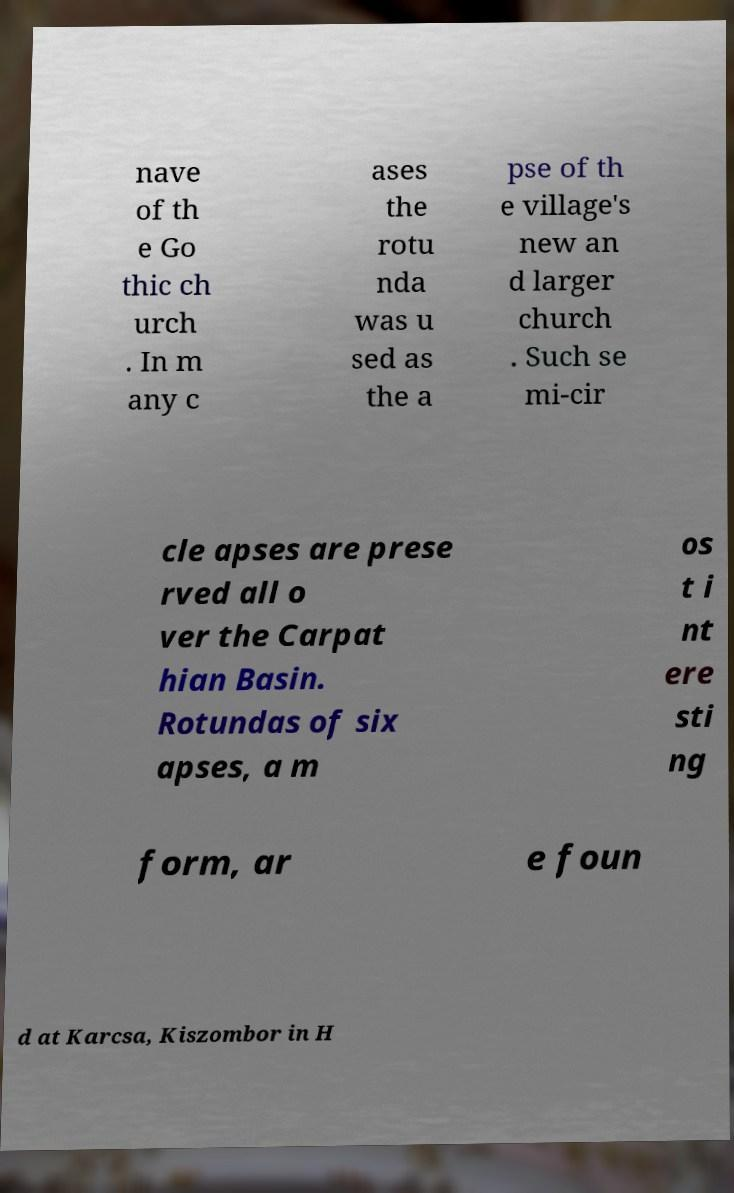Could you assist in decoding the text presented in this image and type it out clearly? nave of th e Go thic ch urch . In m any c ases the rotu nda was u sed as the a pse of th e village's new an d larger church . Such se mi-cir cle apses are prese rved all o ver the Carpat hian Basin. Rotundas of six apses, a m os t i nt ere sti ng form, ar e foun d at Karcsa, Kiszombor in H 